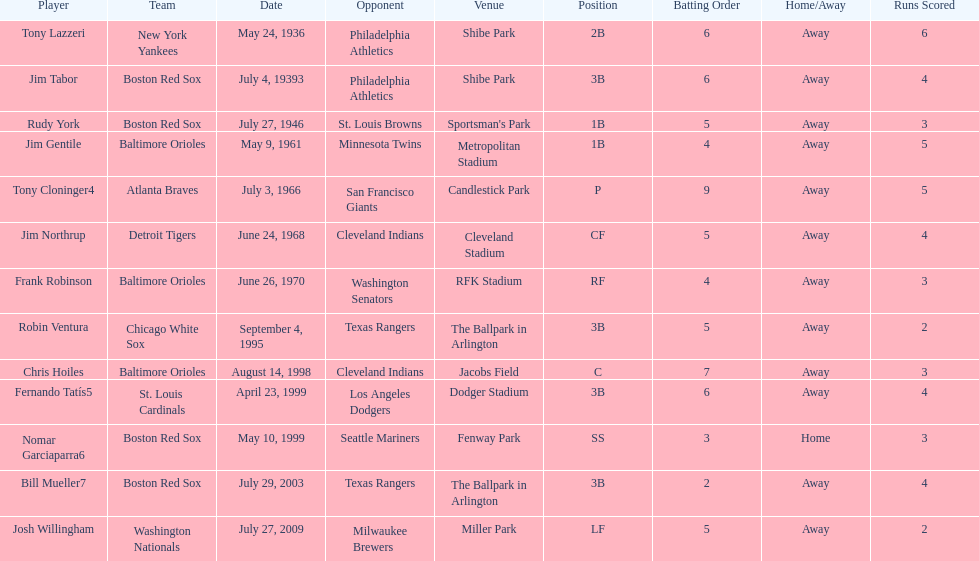What venue did detroit play cleveland in? Cleveland Stadium. Who was the player? Jim Northrup. What date did they play? June 24, 1968. 